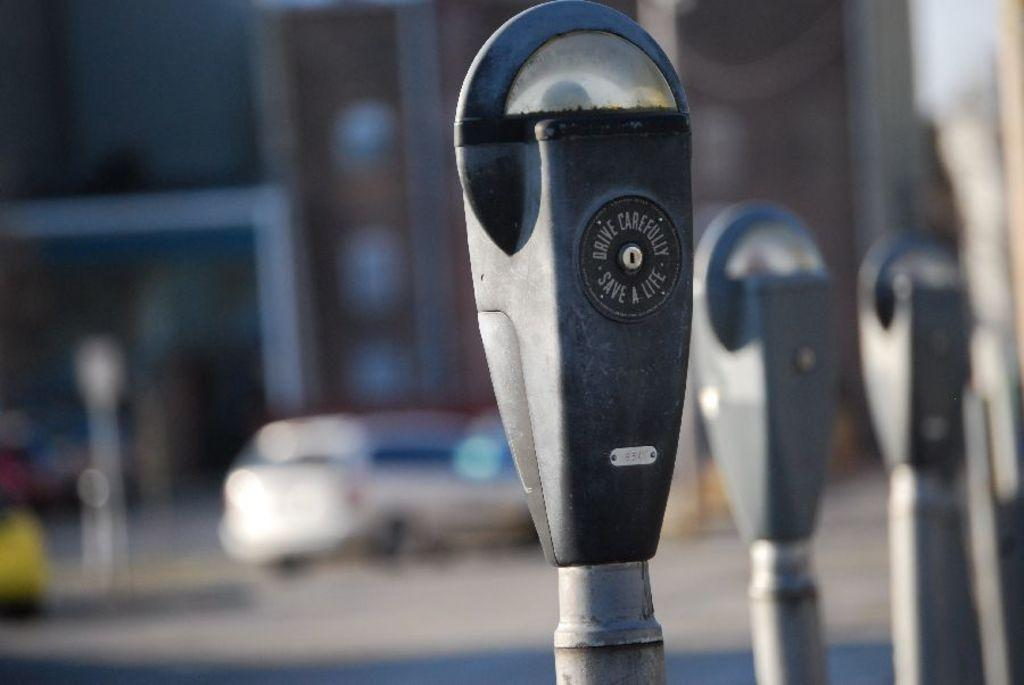<image>
Describe the image concisely. A parking meter has the reminder, Drive Carefully, Save Lives on it. 